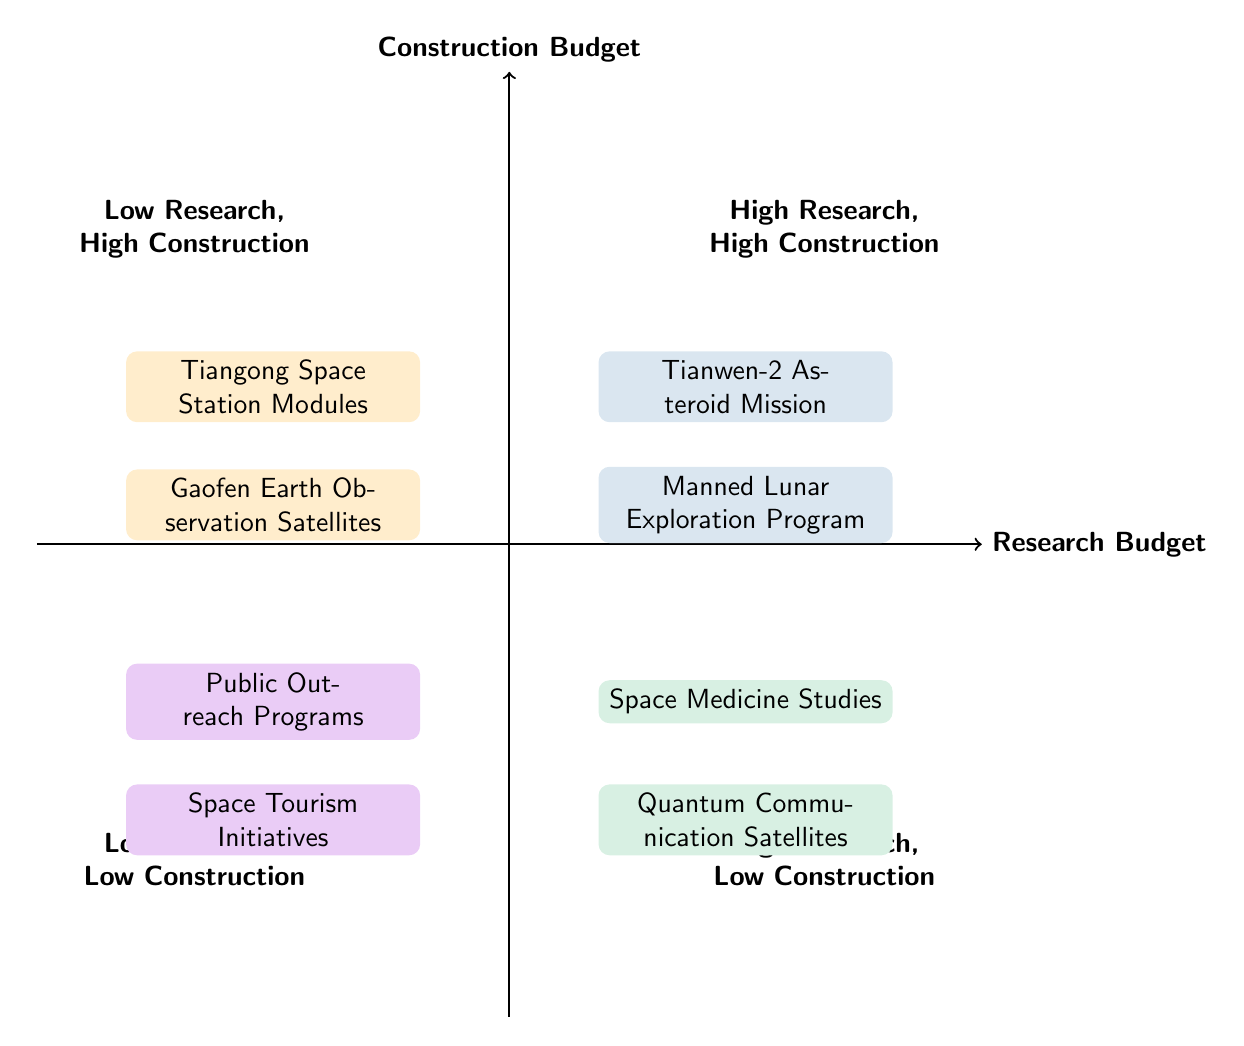What are the two missions in the "High Research, High Construction" quadrant? The "High Research, High Construction" quadrant lists the Tianwen-2 Asteroid Mission and the Manned Lunar Exploration Program as its elements.
Answer: Tianwen-2 Asteroid Mission, Manned Lunar Exploration Program Which quadrant contains "Quantum Communication Satellites"? "Quantum Communication Satellites" is located in the quadrant labeled "High Research, Low Construction".
Answer: High Research, Low Construction How many elements are there in the "Low Research, Low Construction" quadrant? The "Low Research, Low Construction" quadrant contains two elements: Public Outreach Programs and Space Tourism Initiatives, thus the total number of elements is two.
Answer: 2 What is the relationship between "Tiangong Space Station Modules" and "Gaofen Earth Observation Satellites"? Both "Tiangong Space Station Modules" and "Gaofen Earth Observation Satellites" are part of the "Low Research, High Construction" quadrant, indicating that both have low research funding but high construction budgets, representing a similar strategy in budget allocation.
Answer: Low Research, High Construction Which quadrant would you categorize "Space Medicine Studies"? "Space Medicine Studies" is categorized under the "High Research, Low Construction" quadrant, indicating significant funding for research but limited funds for actual construction of spacecraft.
Answer: High Research, Low Construction How many quadrants are there in total? There are four quadrants in the diagram which categorize projects based on research and construction budget allocations.
Answer: 4 Which element is associated with high construction but low research? The elements characterized by high construction but low research, found in the "Low Research, High Construction" quadrant, are Tiangong Space Station Modules and Gaofen Earth Observation Satellites.
Answer: Tiangong Space Station Modules, Gaofen Earth Observation Satellites What is the specific distinction of the "High Research, Low Construction" quadrant compared to the "Low Research, High Construction" quadrant? The key distinction is that the "High Research, Low Construction" quadrant focuses on projects with substantial research investment and minimal construction effort, while the "Low Research, High Construction" quadrant indicates projects that allocate more budget towards construction than research.
Answer: High Research, Low Construction vs. Low Research, High Construction 